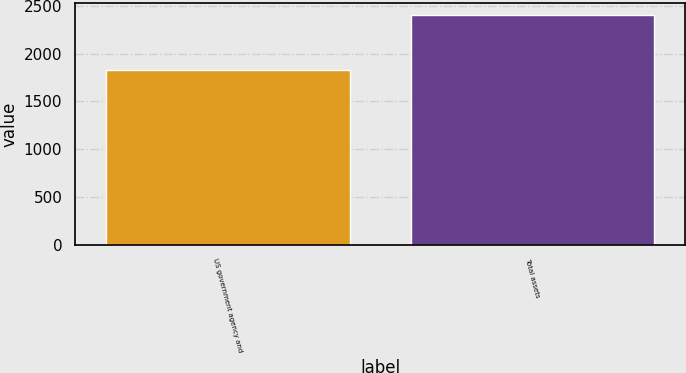<chart> <loc_0><loc_0><loc_500><loc_500><bar_chart><fcel>US government agency and<fcel>Total assets<nl><fcel>1828<fcel>2410<nl></chart> 